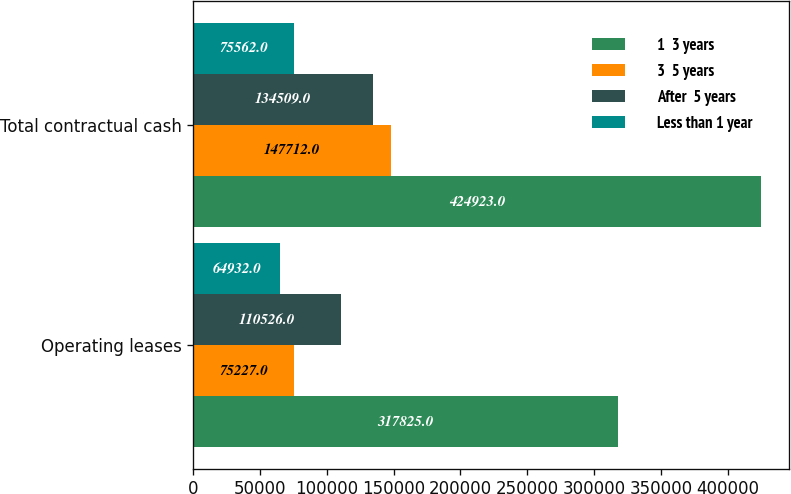Convert chart. <chart><loc_0><loc_0><loc_500><loc_500><stacked_bar_chart><ecel><fcel>Operating leases<fcel>Total contractual cash<nl><fcel>1  3 years<fcel>317825<fcel>424923<nl><fcel>3  5 years<fcel>75227<fcel>147712<nl><fcel>After  5 years<fcel>110526<fcel>134509<nl><fcel>Less than 1 year<fcel>64932<fcel>75562<nl></chart> 